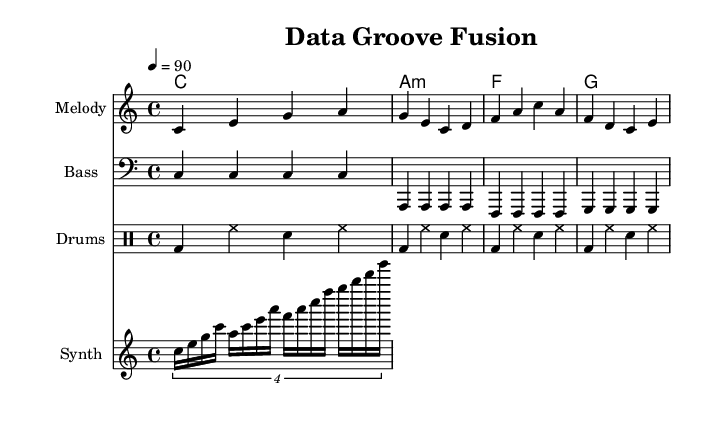What is the key signature of this music? The key signature is C major, which has no sharps or flats.
Answer: C major What is the time signature of this music? The time signature is indicated as 4/4, which means there are four beats in each measure.
Answer: 4/4 What is the tempo of the piece? The tempo is indicated as 90 beats per minute, meaning each quarter note is played at that speed.
Answer: 90 What is the first note of the melody? The first note of the melody is C, which is shown as the lowest note in the initial measure.
Answer: C How many measures are in the bass line? The bass line consists of four measures, which can be counted as there are four groups of notes separated by vertical lines.
Answer: 4 How many different instruments are featured in this score? The score features four different instruments: melody, bass, drums, and synth.
Answer: 4 What type of chords are primarily used in the harmonies section? The harmonies section includes major and minor chords, specifically C major, A minor, F major, and G major, indicating a mix of happy and sad tonalities typical in reggae.
Answer: Major and minor 